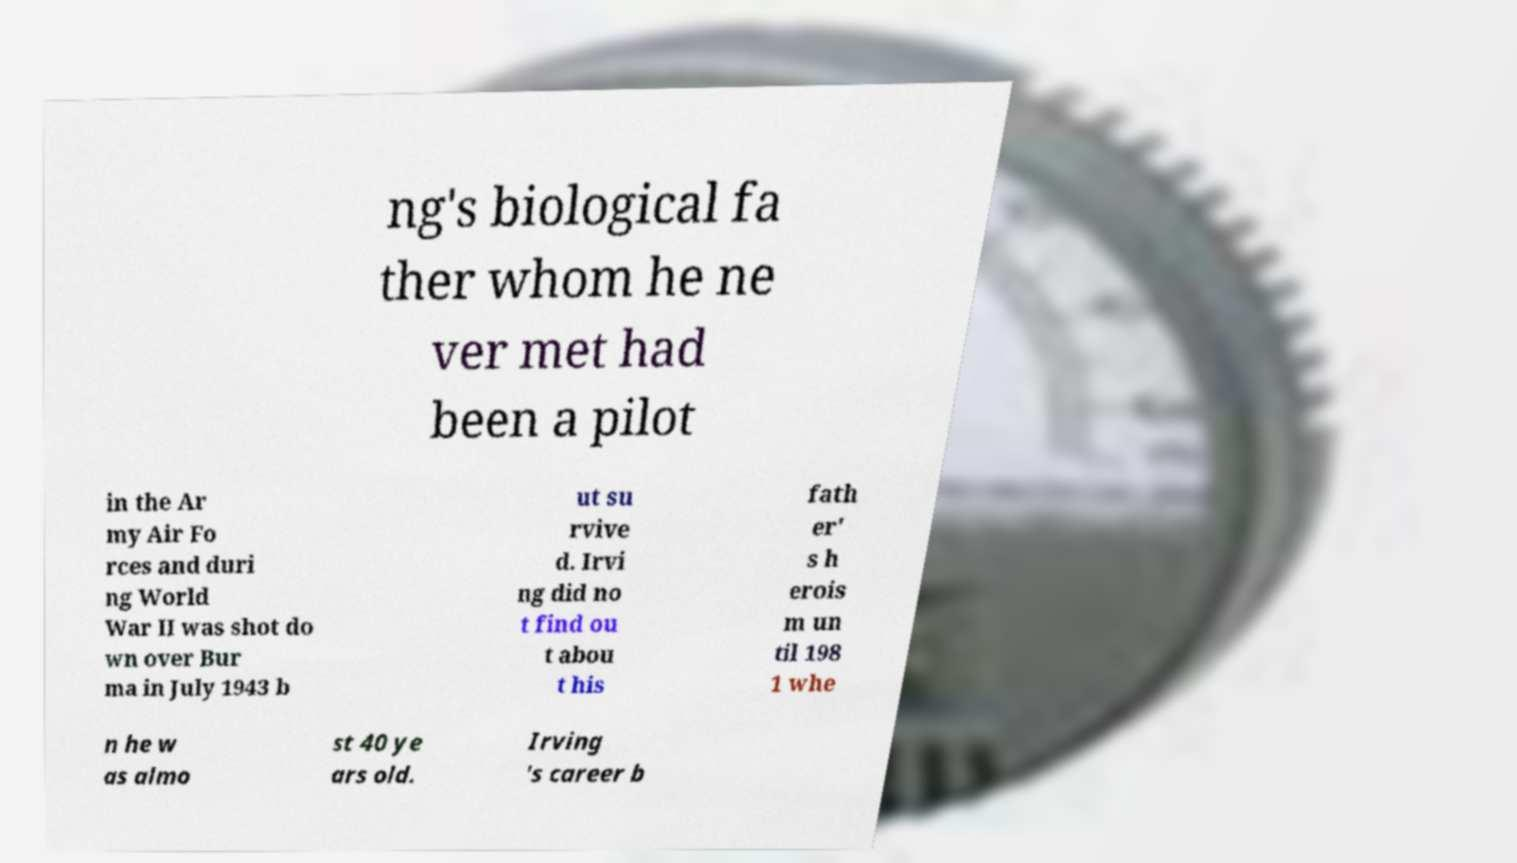For documentation purposes, I need the text within this image transcribed. Could you provide that? ng's biological fa ther whom he ne ver met had been a pilot in the Ar my Air Fo rces and duri ng World War II was shot do wn over Bur ma in July 1943 b ut su rvive d. Irvi ng did no t find ou t abou t his fath er' s h erois m un til 198 1 whe n he w as almo st 40 ye ars old. Irving 's career b 